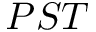Convert formula to latex. <formula><loc_0><loc_0><loc_500><loc_500>P S T</formula> 